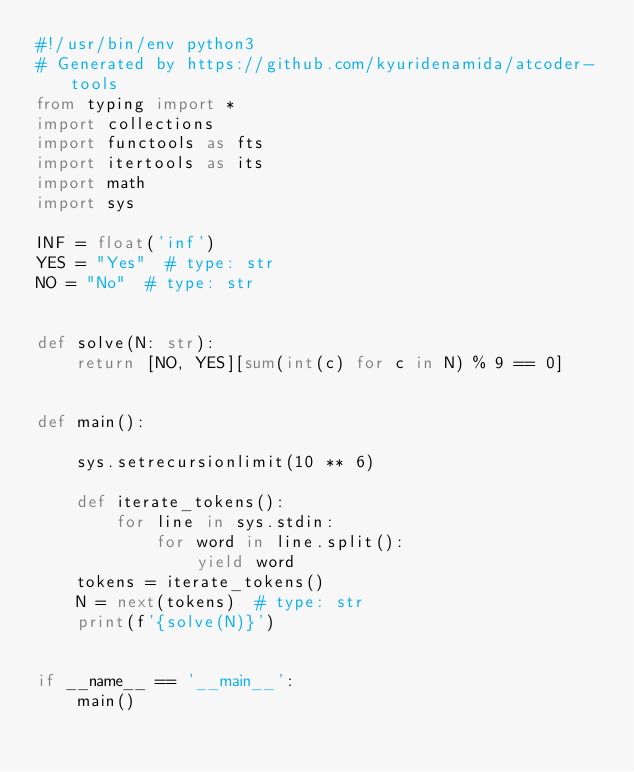Convert code to text. <code><loc_0><loc_0><loc_500><loc_500><_Python_>#!/usr/bin/env python3
# Generated by https://github.com/kyuridenamida/atcoder-tools
from typing import *
import collections
import functools as fts
import itertools as its
import math
import sys

INF = float('inf')
YES = "Yes"  # type: str
NO = "No"  # type: str


def solve(N: str):
    return [NO, YES][sum(int(c) for c in N) % 9 == 0]


def main():

    sys.setrecursionlimit(10 ** 6)

    def iterate_tokens():
        for line in sys.stdin:
            for word in line.split():
                yield word
    tokens = iterate_tokens()
    N = next(tokens)  # type: str
    print(f'{solve(N)}')


if __name__ == '__main__':
    main()
</code> 